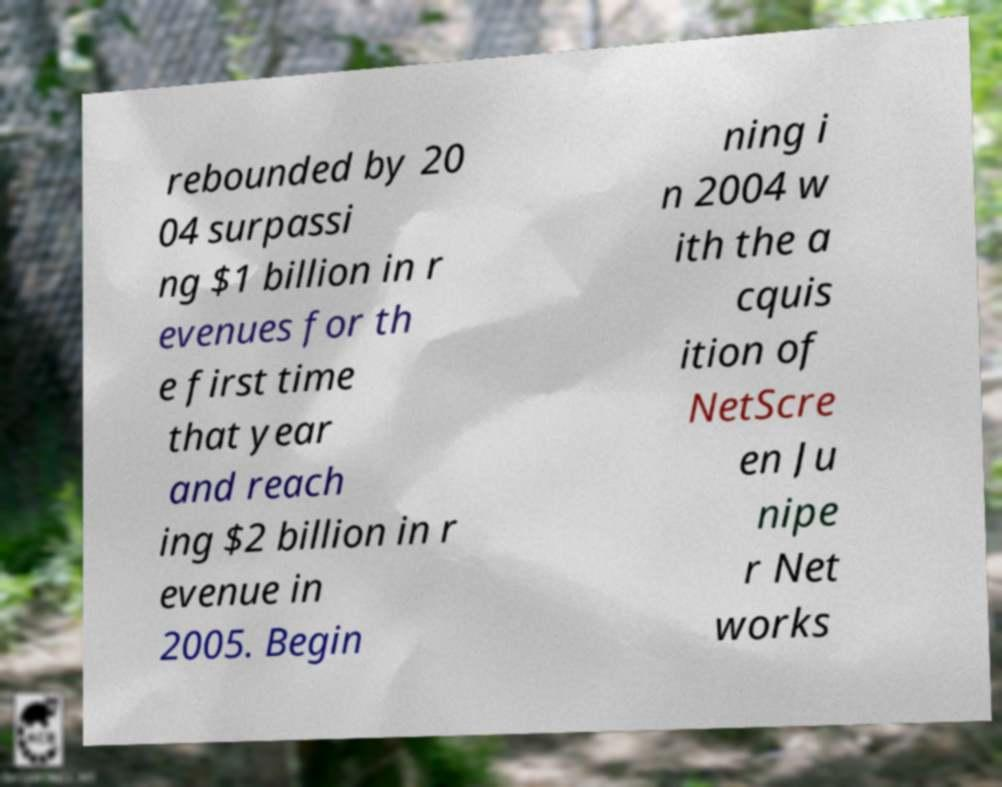Please read and relay the text visible in this image. What does it say? rebounded by 20 04 surpassi ng $1 billion in r evenues for th e first time that year and reach ing $2 billion in r evenue in 2005. Begin ning i n 2004 w ith the a cquis ition of NetScre en Ju nipe r Net works 